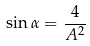<formula> <loc_0><loc_0><loc_500><loc_500>\sin \alpha = \frac { 4 } { A ^ { 2 } }</formula> 